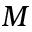Convert formula to latex. <formula><loc_0><loc_0><loc_500><loc_500>M</formula> 